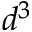<formula> <loc_0><loc_0><loc_500><loc_500>d ^ { 3 }</formula> 